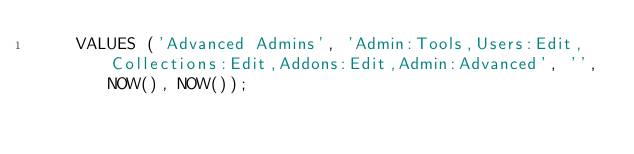Convert code to text. <code><loc_0><loc_0><loc_500><loc_500><_SQL_>    VALUES ('Advanced Admins', 'Admin:Tools,Users:Edit,Collections:Edit,Addons:Edit,Admin:Advanced', '', NOW(), NOW());
</code> 